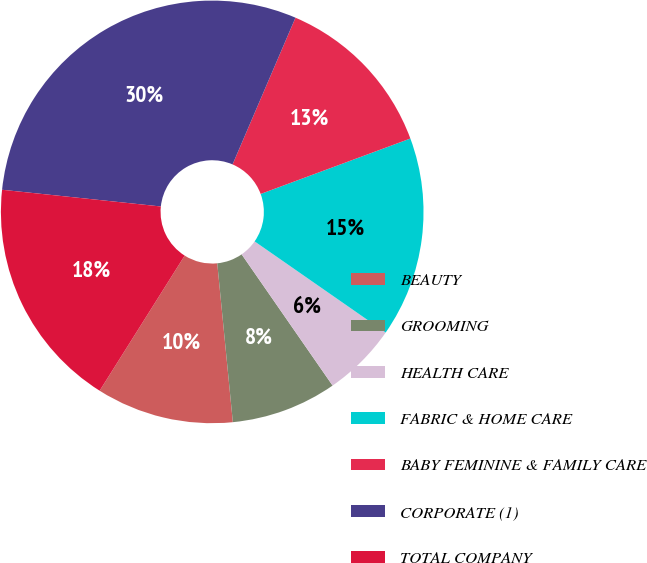<chart> <loc_0><loc_0><loc_500><loc_500><pie_chart><fcel>BEAUTY<fcel>GROOMING<fcel>HEALTH CARE<fcel>FABRIC & HOME CARE<fcel>BABY FEMININE & FAMILY CARE<fcel>CORPORATE (1)<fcel>TOTAL COMPANY<nl><fcel>10.5%<fcel>8.09%<fcel>5.68%<fcel>15.32%<fcel>12.91%<fcel>29.78%<fcel>17.73%<nl></chart> 